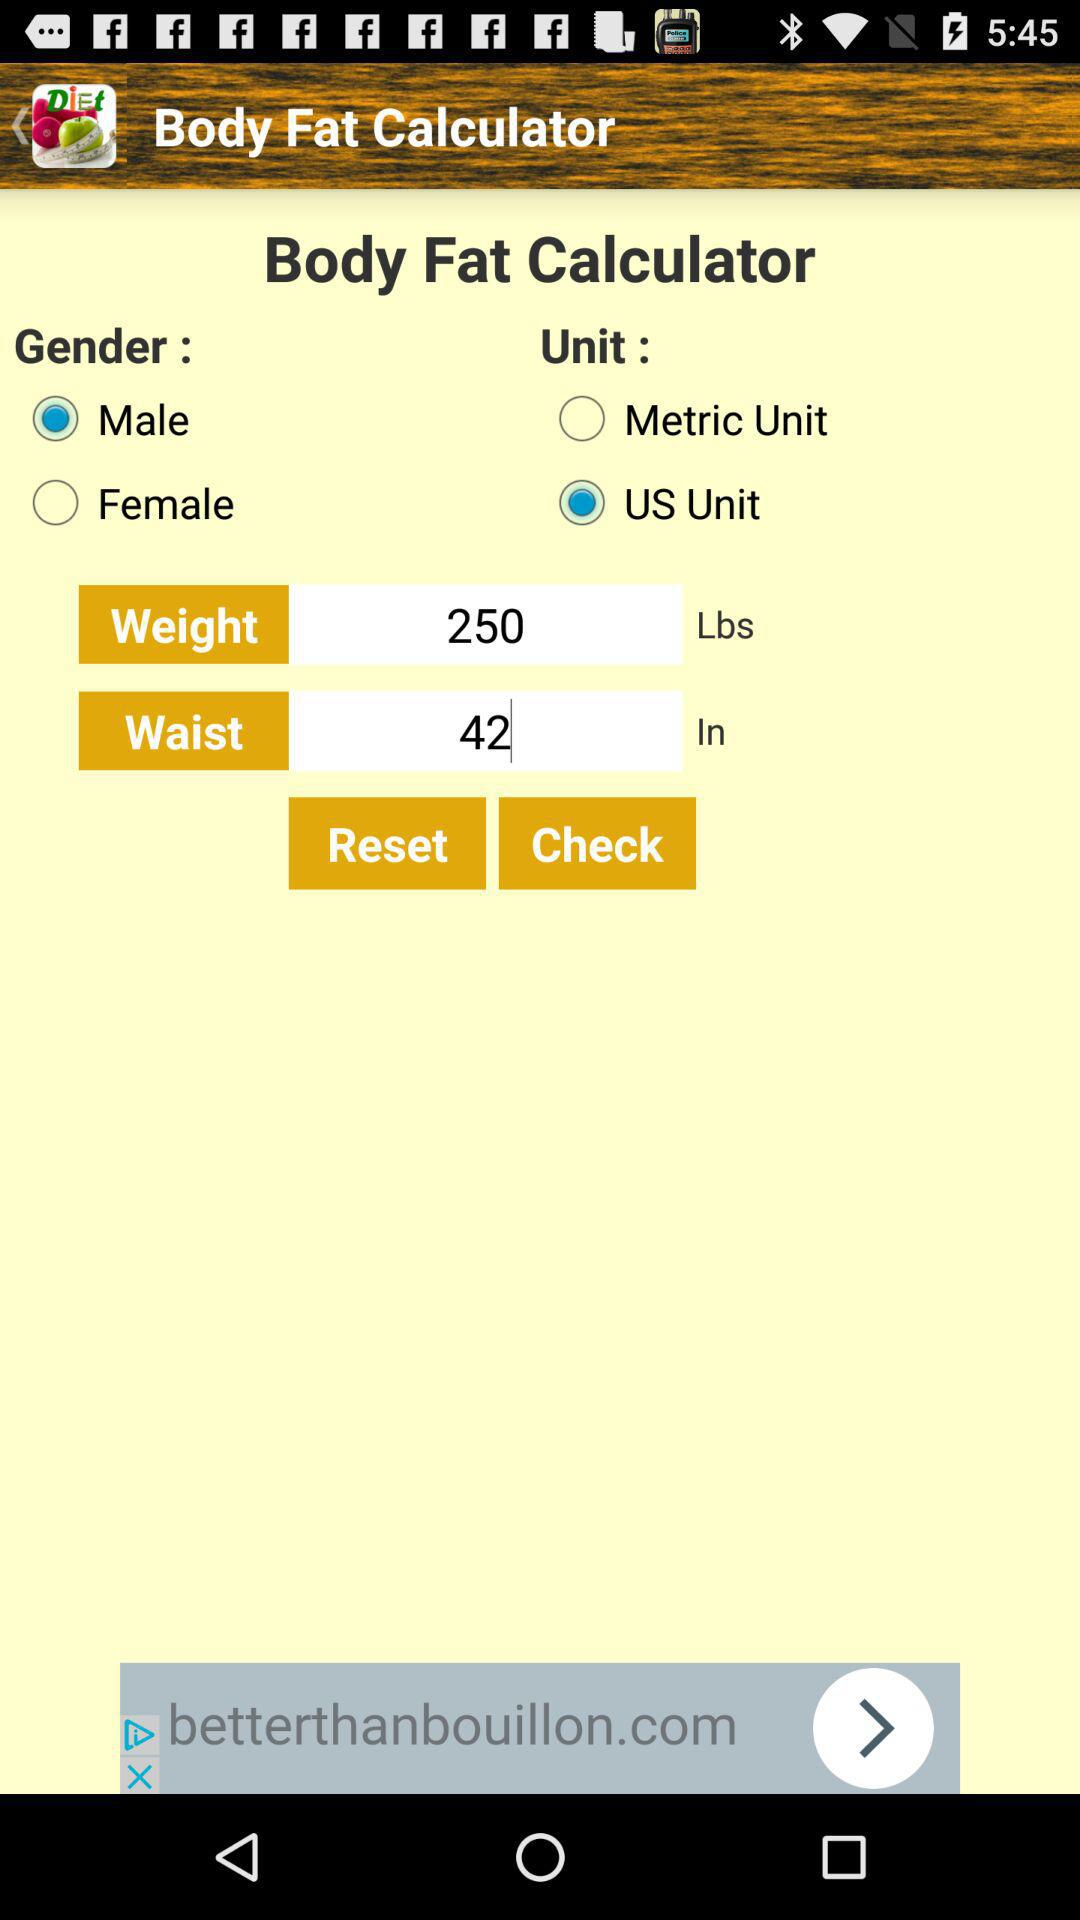What is the selected gender? The selected gender is "Male". 